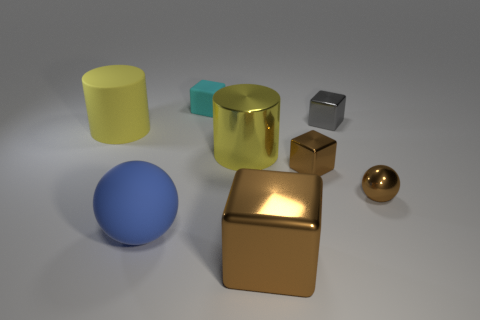Subtract 1 blocks. How many blocks are left? 3 Add 1 yellow things. How many objects exist? 9 Add 2 yellow rubber cylinders. How many yellow rubber cylinders are left? 3 Add 8 tiny gray metallic cubes. How many tiny gray metallic cubes exist? 9 Subtract 0 brown cylinders. How many objects are left? 8 Subtract all big blue objects. Subtract all gray blocks. How many objects are left? 6 